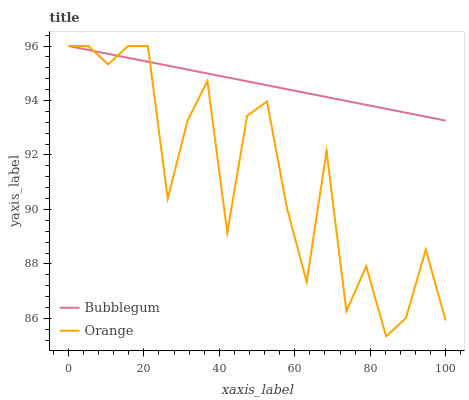Does Bubblegum have the minimum area under the curve?
Answer yes or no. No. Is Bubblegum the roughest?
Answer yes or no. No. Does Bubblegum have the lowest value?
Answer yes or no. No. 